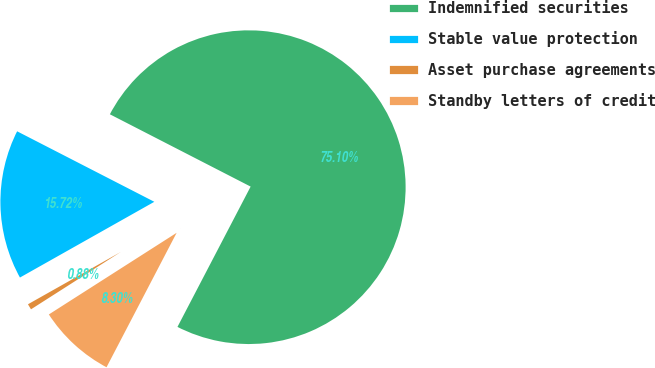<chart> <loc_0><loc_0><loc_500><loc_500><pie_chart><fcel>Indemnified securities<fcel>Stable value protection<fcel>Asset purchase agreements<fcel>Standby letters of credit<nl><fcel>75.09%<fcel>15.72%<fcel>0.88%<fcel>8.3%<nl></chart> 